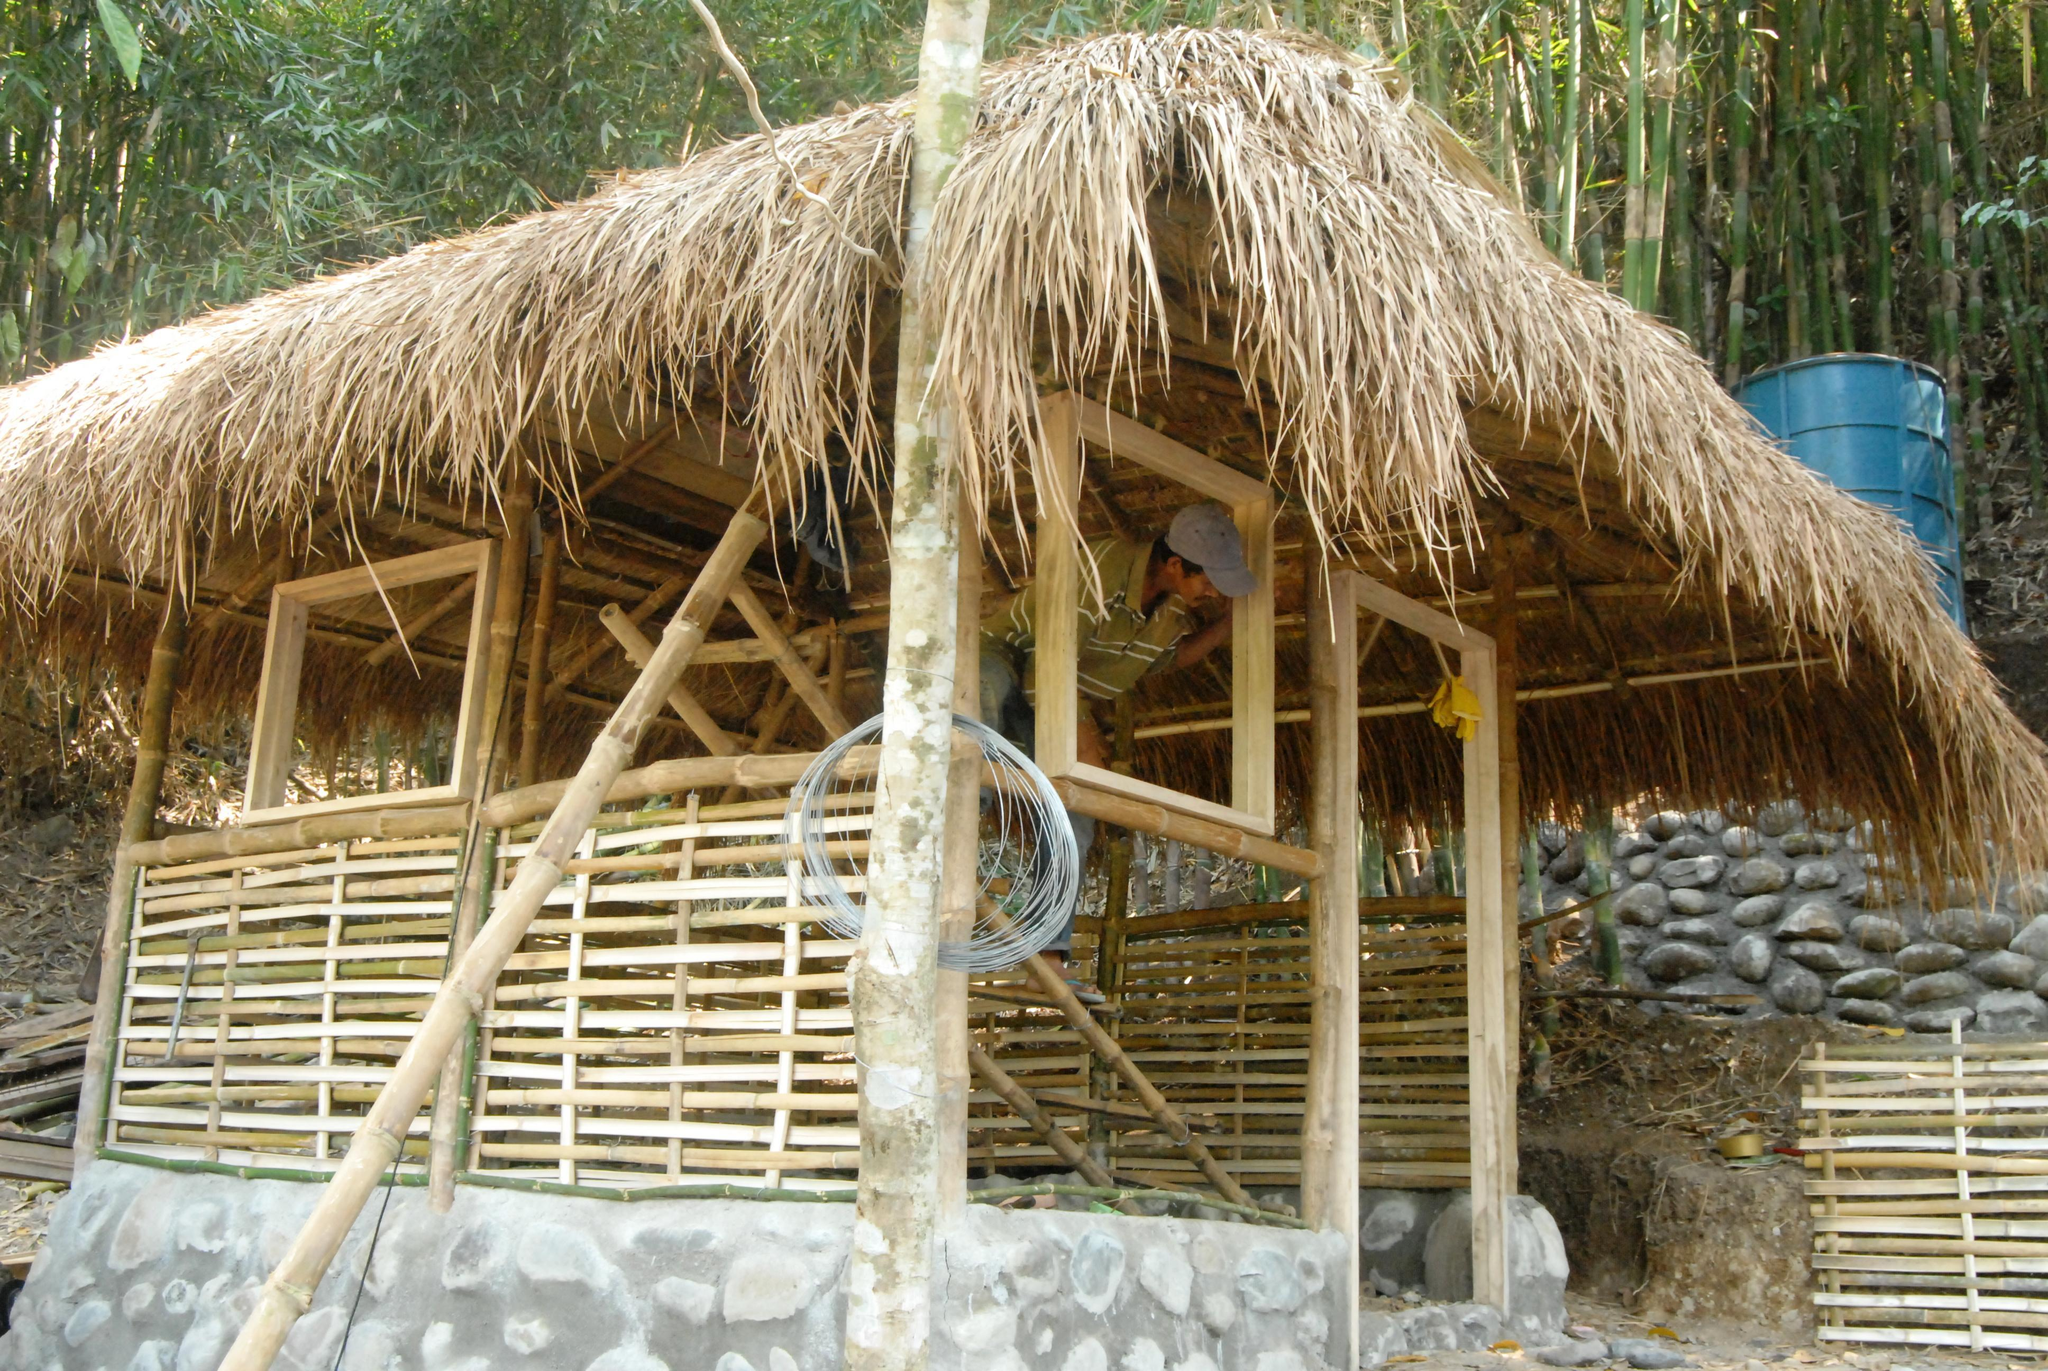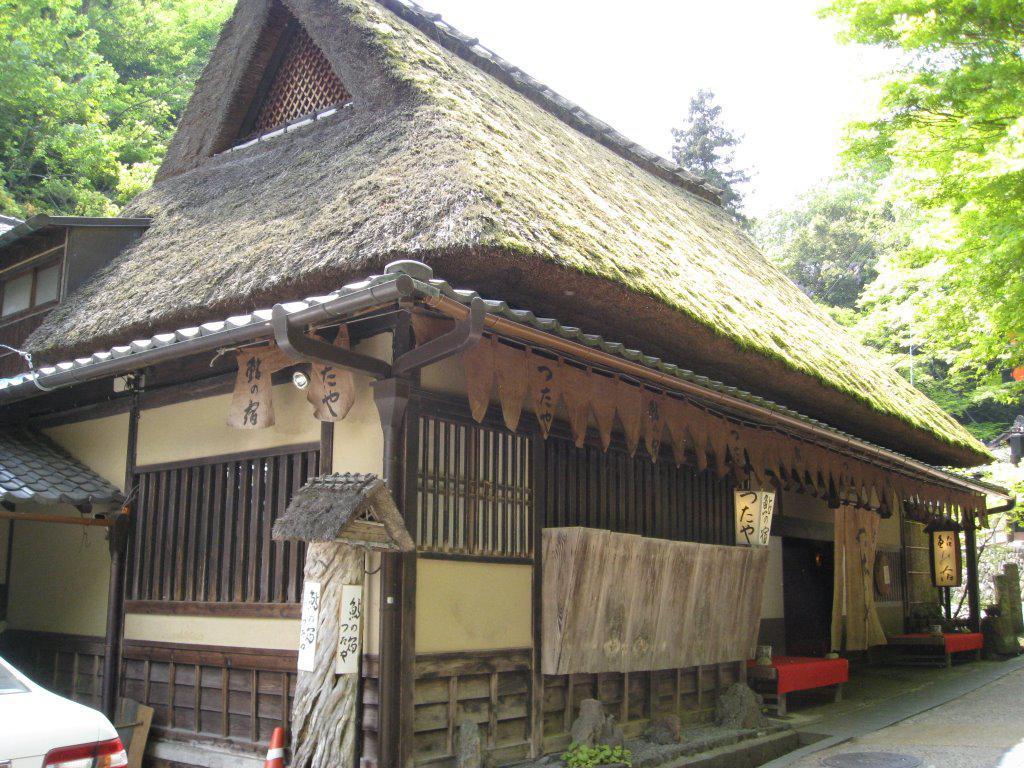The first image is the image on the left, the second image is the image on the right. Evaluate the accuracy of this statement regarding the images: "One house is shaped like a triangle.". Is it true? Answer yes or no. No. The first image is the image on the left, the second image is the image on the right. Examine the images to the left and right. Is the description "In at least one image there is a building with a black hay roof." accurate? Answer yes or no. No. 